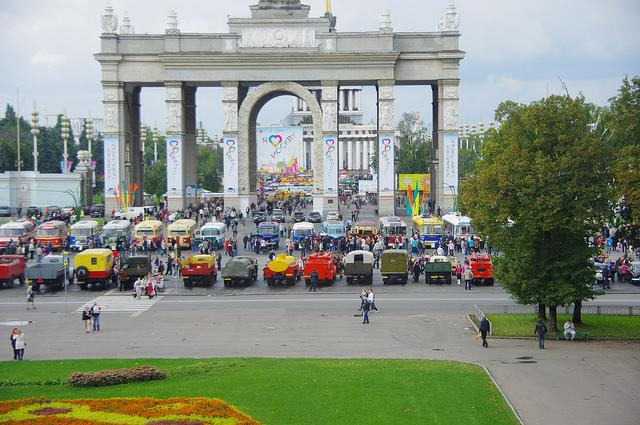The signs are expressing their love for which city? Please explain your reasoning. moscow. The signs are written in russian. 